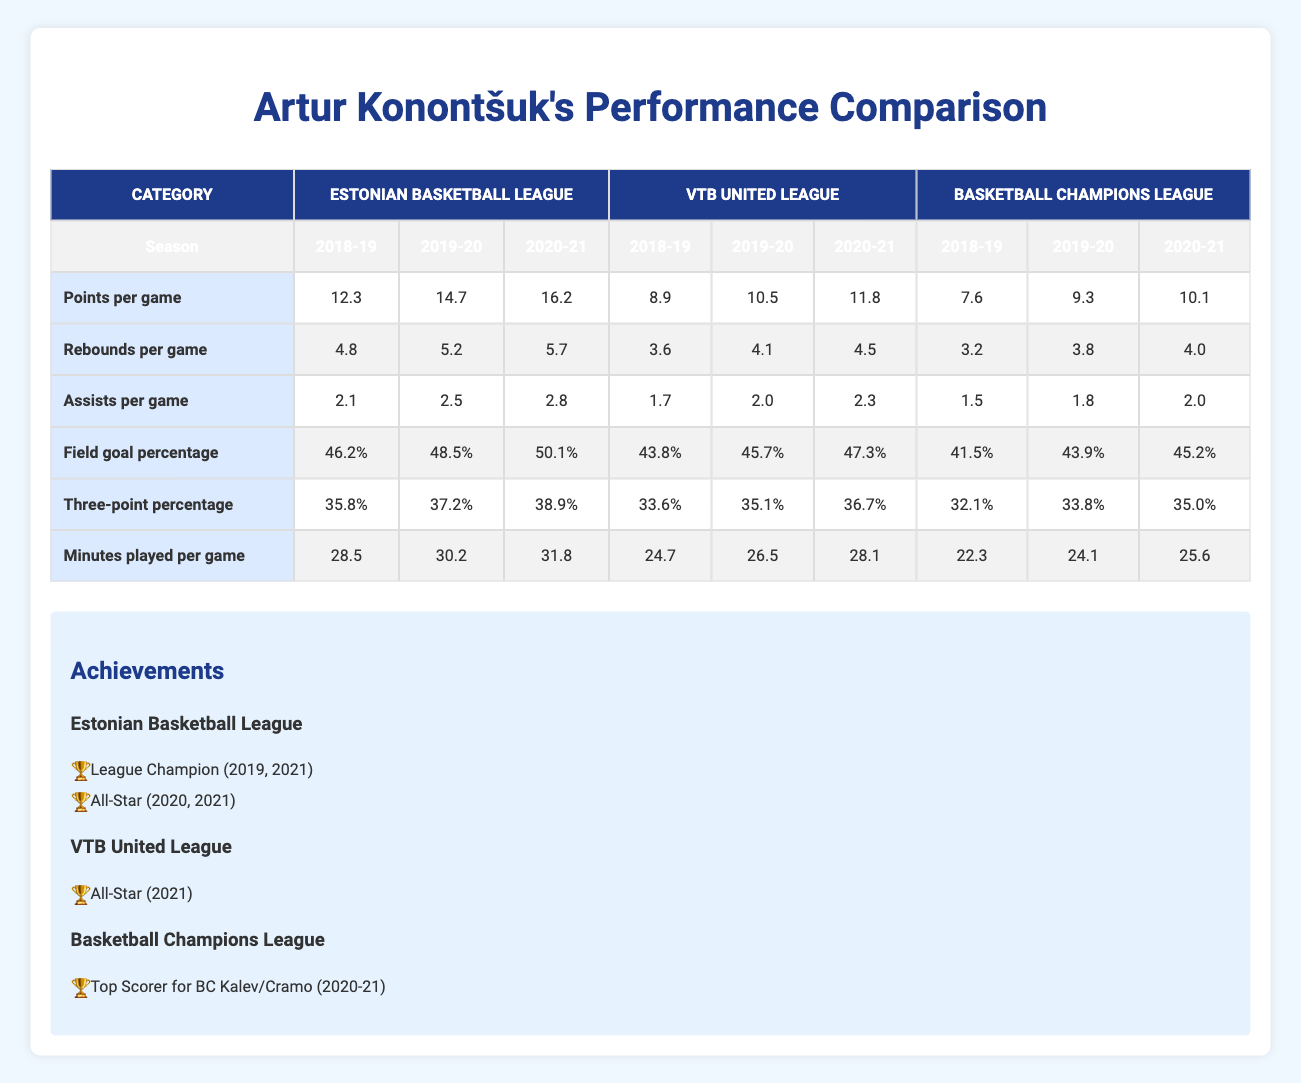What was Artur Konontšuk's highest points per game in the Estonian Basketball League? In the Estonian Basketball League, the highest points per game recorded are from the 2020-21 season, which is 16.2.
Answer: 16.2 Which league had a higher average rebounds per game for Artur Konontšuk in the 2019-20 season, VTB United League or Basketball Champions League? In the 2019-20 season, the rebounds per game were 4.1 for VTB United League and 3.8 for the Basketball Champions League. Since 4.1 is greater than 3.8, VTB United League had a higher average.
Answer: VTB United League What is the average assists per game across all leagues for Artur Konontšuk in the 2020-21 season? For the 2020-21 season, the assists per game were 2.8 in the Estonian Basketball League, 2.3 in VTB United League, and 2.0 in Basketball Champions League. The average is calculated as (2.8 + 2.3 + 2.0) / 3 = 2.366.
Answer: 2.366 Did Artur Konontšuk have a higher field goal percentage in the Estonian Basketball League compared to the Basketball Champions League in the 2018-19 season? In the 2018-19 season, Artur's field goal percentage in the Estonian Basketball League was 46.2% while in the Basketball Champions League it was 41.5%. Since 46.2% is greater than 41.5%, he had a higher percentage in the Estonian Basketball League.
Answer: Yes In which season did Artur Konontšuk achieve the highest three-point percentage in the Estonian Basketball League? Looking at the three-point percentages for the Estonian Basketball League, in the 2020-21 season he achieved the highest at 38.9%.
Answer: 2020-21 What is the difference in minutes played per game between the Estonian Basketball League and the VTB United League for the 2019-20 season? In the 2019-20 season, Artur played 30.2 minutes per game in the Estonian Basketball League and 26.5 minutes per game in the VTB United League. The difference is calculated as 30.2 - 26.5 = 3.7.
Answer: 3.7 Which league had the lowest points per game for Artur Konontšuk in the 2018-19 season? In the 2018-19 season, the points per game were 12.3 in the Estonian Basketball League, 8.9 in the VTB United League, and 7.6 in the Basketball Champions League. The lowest value is from the Basketball Champions League at 7.6.
Answer: Basketball Champions League What is the total number of achievements for Artur Konontšuk in the Estonian Basketball League? Artur has 2 achievements listed for the Estonian Basketball League: League Champion (2019, 2021) and All-Star (2020, 2021), making the total 2.
Answer: 2 Was Artur Konontšuk an All-Star in more than one league? Artur was an All-Star in the Estonian Basketball League for two seasons (2020, 2021) and once in the VTB United League for one season (2021). Therefore, he was an All-Star in more than one league.
Answer: Yes 